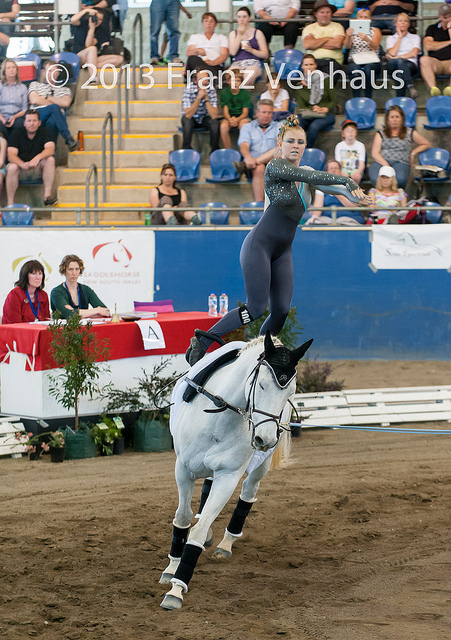<image>What sport is this? I don't know exactly what the sport is. It can be horseback riding, horse dancing, horse acrobatics, rodeo, polo, or equestrian. What sport is this? I don't know what sport this is. It can be horseback riding, horse dancing, horse acrobatics, rodeo, or polo. 